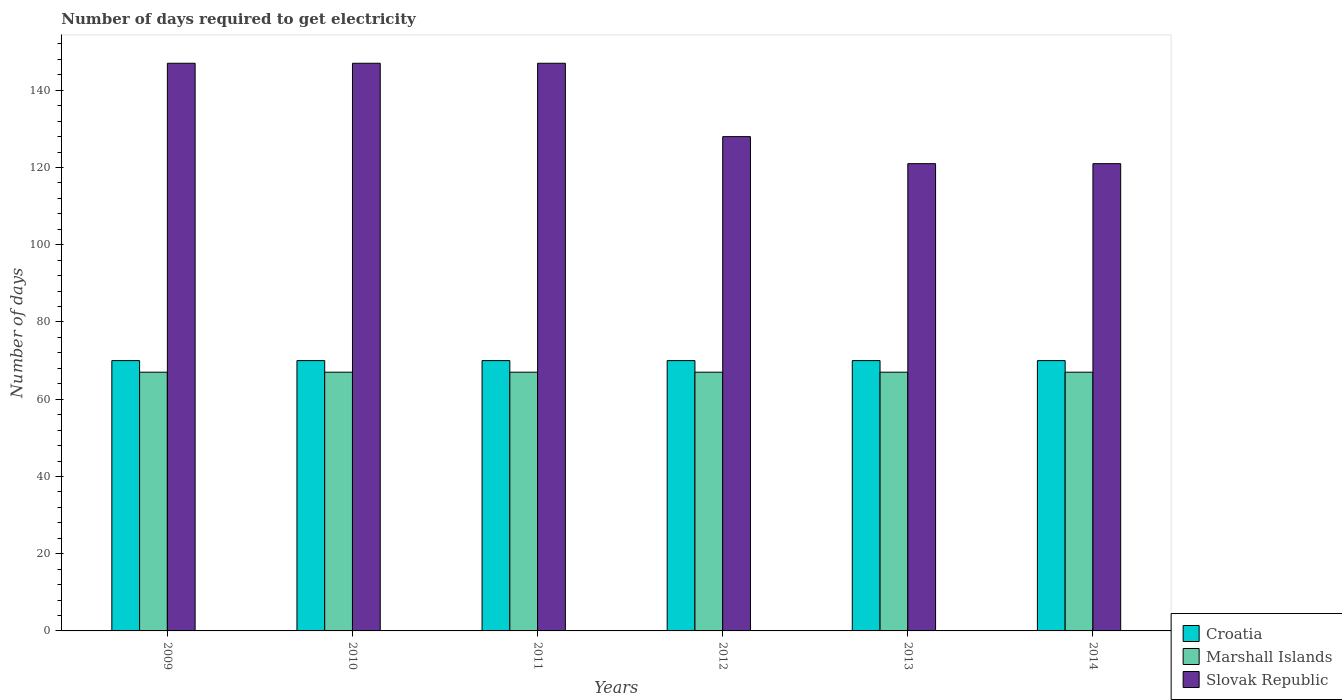How many groups of bars are there?
Ensure brevity in your answer.  6. Are the number of bars on each tick of the X-axis equal?
Keep it short and to the point. Yes. What is the label of the 3rd group of bars from the left?
Give a very brief answer. 2011. In how many cases, is the number of bars for a given year not equal to the number of legend labels?
Keep it short and to the point. 0. What is the number of days required to get electricity in in Marshall Islands in 2009?
Offer a very short reply. 67. Across all years, what is the maximum number of days required to get electricity in in Marshall Islands?
Make the answer very short. 67. Across all years, what is the minimum number of days required to get electricity in in Slovak Republic?
Your answer should be very brief. 121. In which year was the number of days required to get electricity in in Croatia minimum?
Keep it short and to the point. 2009. What is the total number of days required to get electricity in in Marshall Islands in the graph?
Offer a terse response. 402. What is the difference between the number of days required to get electricity in in Slovak Republic in 2012 and that in 2013?
Offer a terse response. 7. What is the difference between the number of days required to get electricity in in Slovak Republic in 2010 and the number of days required to get electricity in in Marshall Islands in 2009?
Offer a terse response. 80. What is the average number of days required to get electricity in in Marshall Islands per year?
Offer a very short reply. 67. In the year 2010, what is the difference between the number of days required to get electricity in in Marshall Islands and number of days required to get electricity in in Croatia?
Provide a succinct answer. -3. In how many years, is the number of days required to get electricity in in Slovak Republic greater than 20 days?
Your answer should be very brief. 6. What is the difference between the highest and the lowest number of days required to get electricity in in Slovak Republic?
Offer a terse response. 26. In how many years, is the number of days required to get electricity in in Marshall Islands greater than the average number of days required to get electricity in in Marshall Islands taken over all years?
Ensure brevity in your answer.  0. Is the sum of the number of days required to get electricity in in Slovak Republic in 2009 and 2013 greater than the maximum number of days required to get electricity in in Marshall Islands across all years?
Your response must be concise. Yes. What does the 2nd bar from the left in 2012 represents?
Your response must be concise. Marshall Islands. What does the 3rd bar from the right in 2013 represents?
Keep it short and to the point. Croatia. How many years are there in the graph?
Provide a succinct answer. 6. Does the graph contain any zero values?
Your answer should be compact. No. Does the graph contain grids?
Your response must be concise. No. What is the title of the graph?
Your answer should be compact. Number of days required to get electricity. What is the label or title of the Y-axis?
Keep it short and to the point. Number of days. What is the Number of days in Marshall Islands in 2009?
Your answer should be very brief. 67. What is the Number of days in Slovak Republic in 2009?
Make the answer very short. 147. What is the Number of days of Croatia in 2010?
Give a very brief answer. 70. What is the Number of days in Marshall Islands in 2010?
Provide a short and direct response. 67. What is the Number of days in Slovak Republic in 2010?
Give a very brief answer. 147. What is the Number of days of Marshall Islands in 2011?
Make the answer very short. 67. What is the Number of days in Slovak Republic in 2011?
Make the answer very short. 147. What is the Number of days in Slovak Republic in 2012?
Ensure brevity in your answer.  128. What is the Number of days of Marshall Islands in 2013?
Make the answer very short. 67. What is the Number of days of Slovak Republic in 2013?
Offer a very short reply. 121. What is the Number of days of Croatia in 2014?
Offer a very short reply. 70. What is the Number of days in Slovak Republic in 2014?
Your response must be concise. 121. Across all years, what is the maximum Number of days of Slovak Republic?
Provide a succinct answer. 147. Across all years, what is the minimum Number of days in Marshall Islands?
Provide a short and direct response. 67. Across all years, what is the minimum Number of days of Slovak Republic?
Provide a short and direct response. 121. What is the total Number of days in Croatia in the graph?
Your answer should be compact. 420. What is the total Number of days of Marshall Islands in the graph?
Offer a terse response. 402. What is the total Number of days of Slovak Republic in the graph?
Your response must be concise. 811. What is the difference between the Number of days of Croatia in 2009 and that in 2010?
Offer a very short reply. 0. What is the difference between the Number of days in Marshall Islands in 2009 and that in 2010?
Provide a succinct answer. 0. What is the difference between the Number of days of Slovak Republic in 2009 and that in 2010?
Keep it short and to the point. 0. What is the difference between the Number of days of Croatia in 2009 and that in 2012?
Give a very brief answer. 0. What is the difference between the Number of days of Marshall Islands in 2009 and that in 2012?
Your response must be concise. 0. What is the difference between the Number of days of Slovak Republic in 2009 and that in 2012?
Provide a short and direct response. 19. What is the difference between the Number of days of Croatia in 2009 and that in 2013?
Your response must be concise. 0. What is the difference between the Number of days of Marshall Islands in 2009 and that in 2013?
Your answer should be compact. 0. What is the difference between the Number of days of Croatia in 2009 and that in 2014?
Offer a terse response. 0. What is the difference between the Number of days in Marshall Islands in 2010 and that in 2011?
Ensure brevity in your answer.  0. What is the difference between the Number of days of Slovak Republic in 2010 and that in 2011?
Provide a succinct answer. 0. What is the difference between the Number of days in Croatia in 2010 and that in 2013?
Ensure brevity in your answer.  0. What is the difference between the Number of days in Croatia in 2010 and that in 2014?
Your response must be concise. 0. What is the difference between the Number of days of Marshall Islands in 2010 and that in 2014?
Give a very brief answer. 0. What is the difference between the Number of days of Slovak Republic in 2011 and that in 2012?
Make the answer very short. 19. What is the difference between the Number of days in Croatia in 2011 and that in 2014?
Your answer should be very brief. 0. What is the difference between the Number of days in Slovak Republic in 2012 and that in 2013?
Give a very brief answer. 7. What is the difference between the Number of days in Slovak Republic in 2012 and that in 2014?
Provide a short and direct response. 7. What is the difference between the Number of days of Croatia in 2013 and that in 2014?
Keep it short and to the point. 0. What is the difference between the Number of days of Marshall Islands in 2013 and that in 2014?
Your answer should be very brief. 0. What is the difference between the Number of days in Croatia in 2009 and the Number of days in Marshall Islands in 2010?
Make the answer very short. 3. What is the difference between the Number of days of Croatia in 2009 and the Number of days of Slovak Republic in 2010?
Offer a very short reply. -77. What is the difference between the Number of days in Marshall Islands in 2009 and the Number of days in Slovak Republic in 2010?
Offer a terse response. -80. What is the difference between the Number of days of Croatia in 2009 and the Number of days of Marshall Islands in 2011?
Provide a succinct answer. 3. What is the difference between the Number of days of Croatia in 2009 and the Number of days of Slovak Republic in 2011?
Offer a terse response. -77. What is the difference between the Number of days in Marshall Islands in 2009 and the Number of days in Slovak Republic in 2011?
Your response must be concise. -80. What is the difference between the Number of days in Croatia in 2009 and the Number of days in Slovak Republic in 2012?
Make the answer very short. -58. What is the difference between the Number of days in Marshall Islands in 2009 and the Number of days in Slovak Republic in 2012?
Give a very brief answer. -61. What is the difference between the Number of days of Croatia in 2009 and the Number of days of Slovak Republic in 2013?
Your answer should be very brief. -51. What is the difference between the Number of days in Marshall Islands in 2009 and the Number of days in Slovak Republic in 2013?
Provide a succinct answer. -54. What is the difference between the Number of days of Croatia in 2009 and the Number of days of Marshall Islands in 2014?
Give a very brief answer. 3. What is the difference between the Number of days of Croatia in 2009 and the Number of days of Slovak Republic in 2014?
Your answer should be very brief. -51. What is the difference between the Number of days of Marshall Islands in 2009 and the Number of days of Slovak Republic in 2014?
Give a very brief answer. -54. What is the difference between the Number of days of Croatia in 2010 and the Number of days of Slovak Republic in 2011?
Offer a terse response. -77. What is the difference between the Number of days of Marshall Islands in 2010 and the Number of days of Slovak Republic in 2011?
Your answer should be compact. -80. What is the difference between the Number of days of Croatia in 2010 and the Number of days of Marshall Islands in 2012?
Provide a succinct answer. 3. What is the difference between the Number of days in Croatia in 2010 and the Number of days in Slovak Republic in 2012?
Your answer should be very brief. -58. What is the difference between the Number of days of Marshall Islands in 2010 and the Number of days of Slovak Republic in 2012?
Offer a very short reply. -61. What is the difference between the Number of days of Croatia in 2010 and the Number of days of Slovak Republic in 2013?
Provide a short and direct response. -51. What is the difference between the Number of days of Marshall Islands in 2010 and the Number of days of Slovak Republic in 2013?
Give a very brief answer. -54. What is the difference between the Number of days of Croatia in 2010 and the Number of days of Slovak Republic in 2014?
Your answer should be compact. -51. What is the difference between the Number of days in Marshall Islands in 2010 and the Number of days in Slovak Republic in 2014?
Your answer should be compact. -54. What is the difference between the Number of days in Croatia in 2011 and the Number of days in Marshall Islands in 2012?
Offer a very short reply. 3. What is the difference between the Number of days of Croatia in 2011 and the Number of days of Slovak Republic in 2012?
Keep it short and to the point. -58. What is the difference between the Number of days of Marshall Islands in 2011 and the Number of days of Slovak Republic in 2012?
Give a very brief answer. -61. What is the difference between the Number of days in Croatia in 2011 and the Number of days in Slovak Republic in 2013?
Ensure brevity in your answer.  -51. What is the difference between the Number of days in Marshall Islands in 2011 and the Number of days in Slovak Republic in 2013?
Provide a short and direct response. -54. What is the difference between the Number of days of Croatia in 2011 and the Number of days of Marshall Islands in 2014?
Offer a terse response. 3. What is the difference between the Number of days of Croatia in 2011 and the Number of days of Slovak Republic in 2014?
Make the answer very short. -51. What is the difference between the Number of days in Marshall Islands in 2011 and the Number of days in Slovak Republic in 2014?
Keep it short and to the point. -54. What is the difference between the Number of days in Croatia in 2012 and the Number of days in Marshall Islands in 2013?
Make the answer very short. 3. What is the difference between the Number of days in Croatia in 2012 and the Number of days in Slovak Republic in 2013?
Keep it short and to the point. -51. What is the difference between the Number of days in Marshall Islands in 2012 and the Number of days in Slovak Republic in 2013?
Keep it short and to the point. -54. What is the difference between the Number of days of Croatia in 2012 and the Number of days of Marshall Islands in 2014?
Give a very brief answer. 3. What is the difference between the Number of days of Croatia in 2012 and the Number of days of Slovak Republic in 2014?
Your answer should be compact. -51. What is the difference between the Number of days in Marshall Islands in 2012 and the Number of days in Slovak Republic in 2014?
Provide a succinct answer. -54. What is the difference between the Number of days of Croatia in 2013 and the Number of days of Slovak Republic in 2014?
Offer a terse response. -51. What is the difference between the Number of days of Marshall Islands in 2013 and the Number of days of Slovak Republic in 2014?
Provide a succinct answer. -54. What is the average Number of days in Croatia per year?
Provide a succinct answer. 70. What is the average Number of days in Slovak Republic per year?
Give a very brief answer. 135.17. In the year 2009, what is the difference between the Number of days of Croatia and Number of days of Marshall Islands?
Make the answer very short. 3. In the year 2009, what is the difference between the Number of days of Croatia and Number of days of Slovak Republic?
Your response must be concise. -77. In the year 2009, what is the difference between the Number of days in Marshall Islands and Number of days in Slovak Republic?
Offer a very short reply. -80. In the year 2010, what is the difference between the Number of days in Croatia and Number of days in Slovak Republic?
Keep it short and to the point. -77. In the year 2010, what is the difference between the Number of days in Marshall Islands and Number of days in Slovak Republic?
Offer a terse response. -80. In the year 2011, what is the difference between the Number of days of Croatia and Number of days of Slovak Republic?
Offer a very short reply. -77. In the year 2011, what is the difference between the Number of days in Marshall Islands and Number of days in Slovak Republic?
Offer a very short reply. -80. In the year 2012, what is the difference between the Number of days of Croatia and Number of days of Marshall Islands?
Provide a short and direct response. 3. In the year 2012, what is the difference between the Number of days in Croatia and Number of days in Slovak Republic?
Your response must be concise. -58. In the year 2012, what is the difference between the Number of days in Marshall Islands and Number of days in Slovak Republic?
Provide a short and direct response. -61. In the year 2013, what is the difference between the Number of days of Croatia and Number of days of Marshall Islands?
Offer a very short reply. 3. In the year 2013, what is the difference between the Number of days in Croatia and Number of days in Slovak Republic?
Offer a terse response. -51. In the year 2013, what is the difference between the Number of days of Marshall Islands and Number of days of Slovak Republic?
Offer a terse response. -54. In the year 2014, what is the difference between the Number of days of Croatia and Number of days of Marshall Islands?
Offer a terse response. 3. In the year 2014, what is the difference between the Number of days in Croatia and Number of days in Slovak Republic?
Ensure brevity in your answer.  -51. In the year 2014, what is the difference between the Number of days of Marshall Islands and Number of days of Slovak Republic?
Your answer should be very brief. -54. What is the ratio of the Number of days of Marshall Islands in 2009 to that in 2010?
Provide a short and direct response. 1. What is the ratio of the Number of days in Slovak Republic in 2009 to that in 2010?
Your answer should be very brief. 1. What is the ratio of the Number of days of Marshall Islands in 2009 to that in 2011?
Provide a succinct answer. 1. What is the ratio of the Number of days in Slovak Republic in 2009 to that in 2011?
Ensure brevity in your answer.  1. What is the ratio of the Number of days in Slovak Republic in 2009 to that in 2012?
Make the answer very short. 1.15. What is the ratio of the Number of days in Slovak Republic in 2009 to that in 2013?
Give a very brief answer. 1.21. What is the ratio of the Number of days in Croatia in 2009 to that in 2014?
Make the answer very short. 1. What is the ratio of the Number of days of Marshall Islands in 2009 to that in 2014?
Provide a succinct answer. 1. What is the ratio of the Number of days in Slovak Republic in 2009 to that in 2014?
Ensure brevity in your answer.  1.21. What is the ratio of the Number of days of Croatia in 2010 to that in 2011?
Give a very brief answer. 1. What is the ratio of the Number of days of Marshall Islands in 2010 to that in 2011?
Offer a very short reply. 1. What is the ratio of the Number of days in Slovak Republic in 2010 to that in 2011?
Make the answer very short. 1. What is the ratio of the Number of days of Croatia in 2010 to that in 2012?
Your answer should be very brief. 1. What is the ratio of the Number of days in Marshall Islands in 2010 to that in 2012?
Offer a very short reply. 1. What is the ratio of the Number of days of Slovak Republic in 2010 to that in 2012?
Your answer should be very brief. 1.15. What is the ratio of the Number of days of Croatia in 2010 to that in 2013?
Provide a short and direct response. 1. What is the ratio of the Number of days in Marshall Islands in 2010 to that in 2013?
Your answer should be compact. 1. What is the ratio of the Number of days of Slovak Republic in 2010 to that in 2013?
Provide a succinct answer. 1.21. What is the ratio of the Number of days of Slovak Republic in 2010 to that in 2014?
Provide a short and direct response. 1.21. What is the ratio of the Number of days in Croatia in 2011 to that in 2012?
Keep it short and to the point. 1. What is the ratio of the Number of days of Marshall Islands in 2011 to that in 2012?
Your answer should be compact. 1. What is the ratio of the Number of days of Slovak Republic in 2011 to that in 2012?
Your answer should be compact. 1.15. What is the ratio of the Number of days in Croatia in 2011 to that in 2013?
Keep it short and to the point. 1. What is the ratio of the Number of days of Marshall Islands in 2011 to that in 2013?
Provide a short and direct response. 1. What is the ratio of the Number of days in Slovak Republic in 2011 to that in 2013?
Provide a succinct answer. 1.21. What is the ratio of the Number of days of Slovak Republic in 2011 to that in 2014?
Make the answer very short. 1.21. What is the ratio of the Number of days in Slovak Republic in 2012 to that in 2013?
Your answer should be compact. 1.06. What is the ratio of the Number of days in Slovak Republic in 2012 to that in 2014?
Your answer should be very brief. 1.06. What is the difference between the highest and the lowest Number of days in Marshall Islands?
Ensure brevity in your answer.  0. What is the difference between the highest and the lowest Number of days in Slovak Republic?
Provide a short and direct response. 26. 